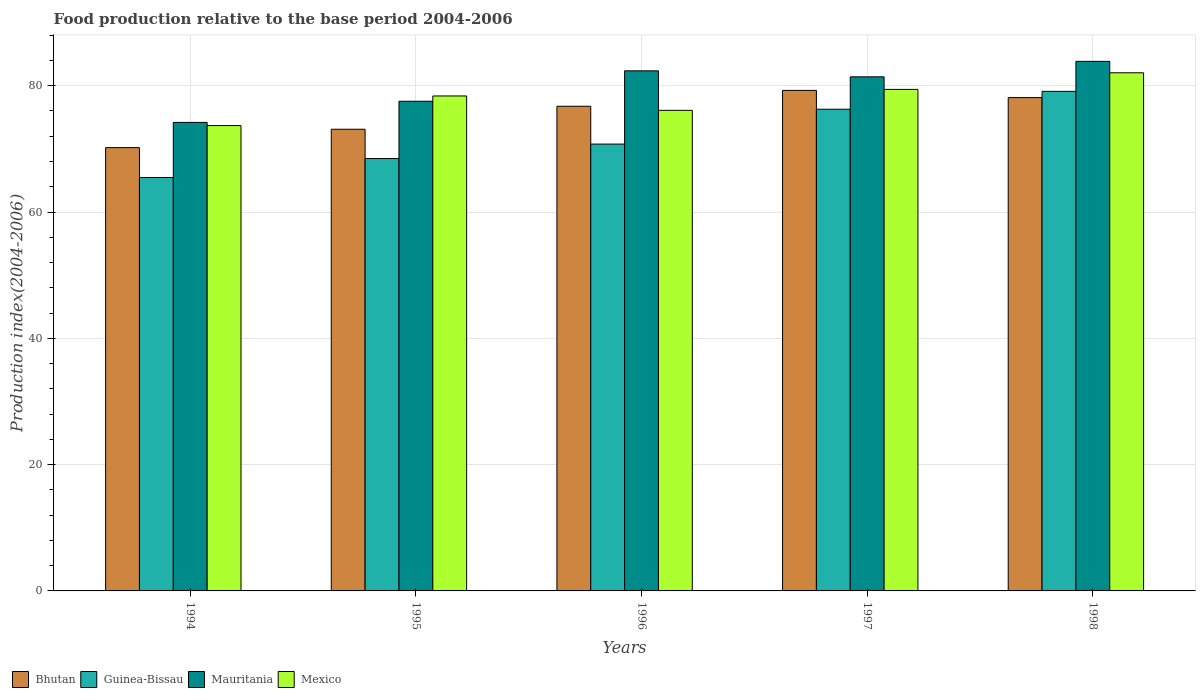Are the number of bars on each tick of the X-axis equal?
Provide a succinct answer. Yes. How many bars are there on the 1st tick from the right?
Give a very brief answer. 4. In how many cases, is the number of bars for a given year not equal to the number of legend labels?
Keep it short and to the point. 0. What is the food production index in Guinea-Bissau in 1996?
Provide a succinct answer. 70.76. Across all years, what is the maximum food production index in Guinea-Bissau?
Your answer should be very brief. 79.11. Across all years, what is the minimum food production index in Mauritania?
Give a very brief answer. 74.19. In which year was the food production index in Mauritania maximum?
Your answer should be very brief. 1998. What is the total food production index in Mexico in the graph?
Keep it short and to the point. 389.64. What is the difference between the food production index in Guinea-Bissau in 1997 and that in 1998?
Keep it short and to the point. -2.83. What is the difference between the food production index in Guinea-Bissau in 1994 and the food production index in Bhutan in 1995?
Give a very brief answer. -7.64. What is the average food production index in Mauritania per year?
Provide a succinct answer. 79.87. In the year 1996, what is the difference between the food production index in Mexico and food production index in Bhutan?
Provide a succinct answer. -0.65. In how many years, is the food production index in Bhutan greater than 24?
Your answer should be compact. 5. What is the ratio of the food production index in Bhutan in 1995 to that in 1997?
Ensure brevity in your answer.  0.92. Is the food production index in Guinea-Bissau in 1997 less than that in 1998?
Provide a short and direct response. Yes. What is the difference between the highest and the second highest food production index in Mexico?
Offer a terse response. 2.63. What is the difference between the highest and the lowest food production index in Mauritania?
Your answer should be very brief. 9.67. Is the sum of the food production index in Mexico in 1994 and 1997 greater than the maximum food production index in Bhutan across all years?
Your response must be concise. Yes. What does the 4th bar from the left in 1997 represents?
Ensure brevity in your answer.  Mexico. What does the 1st bar from the right in 1994 represents?
Offer a terse response. Mexico. Is it the case that in every year, the sum of the food production index in Guinea-Bissau and food production index in Mexico is greater than the food production index in Bhutan?
Keep it short and to the point. Yes. How many bars are there?
Your answer should be very brief. 20. Are the values on the major ticks of Y-axis written in scientific E-notation?
Provide a short and direct response. No. Does the graph contain any zero values?
Provide a short and direct response. No. Does the graph contain grids?
Give a very brief answer. Yes. What is the title of the graph?
Your response must be concise. Food production relative to the base period 2004-2006. Does "Slovenia" appear as one of the legend labels in the graph?
Your answer should be compact. No. What is the label or title of the X-axis?
Keep it short and to the point. Years. What is the label or title of the Y-axis?
Keep it short and to the point. Production index(2004-2006). What is the Production index(2004-2006) of Bhutan in 1994?
Your response must be concise. 70.2. What is the Production index(2004-2006) of Guinea-Bissau in 1994?
Offer a terse response. 65.47. What is the Production index(2004-2006) in Mauritania in 1994?
Your answer should be compact. 74.19. What is the Production index(2004-2006) of Mexico in 1994?
Your answer should be compact. 73.69. What is the Production index(2004-2006) of Bhutan in 1995?
Keep it short and to the point. 73.11. What is the Production index(2004-2006) of Guinea-Bissau in 1995?
Your response must be concise. 68.47. What is the Production index(2004-2006) of Mauritania in 1995?
Your answer should be very brief. 77.54. What is the Production index(2004-2006) in Mexico in 1995?
Your answer should be very brief. 78.38. What is the Production index(2004-2006) in Bhutan in 1996?
Give a very brief answer. 76.75. What is the Production index(2004-2006) in Guinea-Bissau in 1996?
Keep it short and to the point. 70.76. What is the Production index(2004-2006) of Mauritania in 1996?
Keep it short and to the point. 82.36. What is the Production index(2004-2006) in Mexico in 1996?
Ensure brevity in your answer.  76.1. What is the Production index(2004-2006) in Bhutan in 1997?
Offer a very short reply. 79.26. What is the Production index(2004-2006) in Guinea-Bissau in 1997?
Give a very brief answer. 76.28. What is the Production index(2004-2006) in Mauritania in 1997?
Keep it short and to the point. 81.41. What is the Production index(2004-2006) of Mexico in 1997?
Your answer should be very brief. 79.42. What is the Production index(2004-2006) in Bhutan in 1998?
Provide a short and direct response. 78.12. What is the Production index(2004-2006) in Guinea-Bissau in 1998?
Your answer should be compact. 79.11. What is the Production index(2004-2006) of Mauritania in 1998?
Your answer should be very brief. 83.86. What is the Production index(2004-2006) in Mexico in 1998?
Ensure brevity in your answer.  82.05. Across all years, what is the maximum Production index(2004-2006) of Bhutan?
Give a very brief answer. 79.26. Across all years, what is the maximum Production index(2004-2006) of Guinea-Bissau?
Provide a succinct answer. 79.11. Across all years, what is the maximum Production index(2004-2006) of Mauritania?
Your answer should be very brief. 83.86. Across all years, what is the maximum Production index(2004-2006) in Mexico?
Offer a terse response. 82.05. Across all years, what is the minimum Production index(2004-2006) of Bhutan?
Make the answer very short. 70.2. Across all years, what is the minimum Production index(2004-2006) of Guinea-Bissau?
Make the answer very short. 65.47. Across all years, what is the minimum Production index(2004-2006) in Mauritania?
Give a very brief answer. 74.19. Across all years, what is the minimum Production index(2004-2006) in Mexico?
Keep it short and to the point. 73.69. What is the total Production index(2004-2006) in Bhutan in the graph?
Ensure brevity in your answer.  377.44. What is the total Production index(2004-2006) of Guinea-Bissau in the graph?
Your response must be concise. 360.09. What is the total Production index(2004-2006) in Mauritania in the graph?
Keep it short and to the point. 399.36. What is the total Production index(2004-2006) in Mexico in the graph?
Your answer should be very brief. 389.64. What is the difference between the Production index(2004-2006) in Bhutan in 1994 and that in 1995?
Make the answer very short. -2.91. What is the difference between the Production index(2004-2006) in Guinea-Bissau in 1994 and that in 1995?
Provide a succinct answer. -3. What is the difference between the Production index(2004-2006) in Mauritania in 1994 and that in 1995?
Offer a terse response. -3.35. What is the difference between the Production index(2004-2006) in Mexico in 1994 and that in 1995?
Provide a short and direct response. -4.69. What is the difference between the Production index(2004-2006) in Bhutan in 1994 and that in 1996?
Provide a short and direct response. -6.55. What is the difference between the Production index(2004-2006) in Guinea-Bissau in 1994 and that in 1996?
Provide a succinct answer. -5.29. What is the difference between the Production index(2004-2006) of Mauritania in 1994 and that in 1996?
Offer a terse response. -8.17. What is the difference between the Production index(2004-2006) in Mexico in 1994 and that in 1996?
Offer a terse response. -2.41. What is the difference between the Production index(2004-2006) of Bhutan in 1994 and that in 1997?
Provide a succinct answer. -9.06. What is the difference between the Production index(2004-2006) in Guinea-Bissau in 1994 and that in 1997?
Provide a short and direct response. -10.81. What is the difference between the Production index(2004-2006) in Mauritania in 1994 and that in 1997?
Provide a short and direct response. -7.22. What is the difference between the Production index(2004-2006) in Mexico in 1994 and that in 1997?
Give a very brief answer. -5.73. What is the difference between the Production index(2004-2006) in Bhutan in 1994 and that in 1998?
Provide a short and direct response. -7.92. What is the difference between the Production index(2004-2006) in Guinea-Bissau in 1994 and that in 1998?
Ensure brevity in your answer.  -13.64. What is the difference between the Production index(2004-2006) of Mauritania in 1994 and that in 1998?
Your answer should be very brief. -9.67. What is the difference between the Production index(2004-2006) of Mexico in 1994 and that in 1998?
Give a very brief answer. -8.36. What is the difference between the Production index(2004-2006) of Bhutan in 1995 and that in 1996?
Provide a short and direct response. -3.64. What is the difference between the Production index(2004-2006) in Guinea-Bissau in 1995 and that in 1996?
Keep it short and to the point. -2.29. What is the difference between the Production index(2004-2006) of Mauritania in 1995 and that in 1996?
Give a very brief answer. -4.82. What is the difference between the Production index(2004-2006) in Mexico in 1995 and that in 1996?
Give a very brief answer. 2.28. What is the difference between the Production index(2004-2006) of Bhutan in 1995 and that in 1997?
Ensure brevity in your answer.  -6.15. What is the difference between the Production index(2004-2006) in Guinea-Bissau in 1995 and that in 1997?
Provide a succinct answer. -7.81. What is the difference between the Production index(2004-2006) in Mauritania in 1995 and that in 1997?
Ensure brevity in your answer.  -3.87. What is the difference between the Production index(2004-2006) of Mexico in 1995 and that in 1997?
Offer a very short reply. -1.04. What is the difference between the Production index(2004-2006) of Bhutan in 1995 and that in 1998?
Give a very brief answer. -5.01. What is the difference between the Production index(2004-2006) of Guinea-Bissau in 1995 and that in 1998?
Your response must be concise. -10.64. What is the difference between the Production index(2004-2006) in Mauritania in 1995 and that in 1998?
Provide a succinct answer. -6.32. What is the difference between the Production index(2004-2006) in Mexico in 1995 and that in 1998?
Keep it short and to the point. -3.67. What is the difference between the Production index(2004-2006) in Bhutan in 1996 and that in 1997?
Your answer should be very brief. -2.51. What is the difference between the Production index(2004-2006) of Guinea-Bissau in 1996 and that in 1997?
Keep it short and to the point. -5.52. What is the difference between the Production index(2004-2006) in Mauritania in 1996 and that in 1997?
Your answer should be compact. 0.95. What is the difference between the Production index(2004-2006) in Mexico in 1996 and that in 1997?
Make the answer very short. -3.32. What is the difference between the Production index(2004-2006) in Bhutan in 1996 and that in 1998?
Offer a very short reply. -1.37. What is the difference between the Production index(2004-2006) in Guinea-Bissau in 1996 and that in 1998?
Ensure brevity in your answer.  -8.35. What is the difference between the Production index(2004-2006) in Mexico in 1996 and that in 1998?
Offer a terse response. -5.95. What is the difference between the Production index(2004-2006) of Bhutan in 1997 and that in 1998?
Offer a terse response. 1.14. What is the difference between the Production index(2004-2006) of Guinea-Bissau in 1997 and that in 1998?
Provide a short and direct response. -2.83. What is the difference between the Production index(2004-2006) in Mauritania in 1997 and that in 1998?
Offer a terse response. -2.45. What is the difference between the Production index(2004-2006) in Mexico in 1997 and that in 1998?
Make the answer very short. -2.63. What is the difference between the Production index(2004-2006) in Bhutan in 1994 and the Production index(2004-2006) in Guinea-Bissau in 1995?
Your answer should be very brief. 1.73. What is the difference between the Production index(2004-2006) in Bhutan in 1994 and the Production index(2004-2006) in Mauritania in 1995?
Provide a short and direct response. -7.34. What is the difference between the Production index(2004-2006) in Bhutan in 1994 and the Production index(2004-2006) in Mexico in 1995?
Your answer should be very brief. -8.18. What is the difference between the Production index(2004-2006) in Guinea-Bissau in 1994 and the Production index(2004-2006) in Mauritania in 1995?
Offer a terse response. -12.07. What is the difference between the Production index(2004-2006) in Guinea-Bissau in 1994 and the Production index(2004-2006) in Mexico in 1995?
Provide a short and direct response. -12.91. What is the difference between the Production index(2004-2006) in Mauritania in 1994 and the Production index(2004-2006) in Mexico in 1995?
Your answer should be compact. -4.19. What is the difference between the Production index(2004-2006) in Bhutan in 1994 and the Production index(2004-2006) in Guinea-Bissau in 1996?
Your answer should be compact. -0.56. What is the difference between the Production index(2004-2006) in Bhutan in 1994 and the Production index(2004-2006) in Mauritania in 1996?
Make the answer very short. -12.16. What is the difference between the Production index(2004-2006) in Bhutan in 1994 and the Production index(2004-2006) in Mexico in 1996?
Your answer should be very brief. -5.9. What is the difference between the Production index(2004-2006) in Guinea-Bissau in 1994 and the Production index(2004-2006) in Mauritania in 1996?
Provide a succinct answer. -16.89. What is the difference between the Production index(2004-2006) in Guinea-Bissau in 1994 and the Production index(2004-2006) in Mexico in 1996?
Offer a terse response. -10.63. What is the difference between the Production index(2004-2006) of Mauritania in 1994 and the Production index(2004-2006) of Mexico in 1996?
Keep it short and to the point. -1.91. What is the difference between the Production index(2004-2006) of Bhutan in 1994 and the Production index(2004-2006) of Guinea-Bissau in 1997?
Offer a terse response. -6.08. What is the difference between the Production index(2004-2006) of Bhutan in 1994 and the Production index(2004-2006) of Mauritania in 1997?
Your answer should be very brief. -11.21. What is the difference between the Production index(2004-2006) of Bhutan in 1994 and the Production index(2004-2006) of Mexico in 1997?
Provide a short and direct response. -9.22. What is the difference between the Production index(2004-2006) of Guinea-Bissau in 1994 and the Production index(2004-2006) of Mauritania in 1997?
Ensure brevity in your answer.  -15.94. What is the difference between the Production index(2004-2006) of Guinea-Bissau in 1994 and the Production index(2004-2006) of Mexico in 1997?
Make the answer very short. -13.95. What is the difference between the Production index(2004-2006) in Mauritania in 1994 and the Production index(2004-2006) in Mexico in 1997?
Provide a succinct answer. -5.23. What is the difference between the Production index(2004-2006) in Bhutan in 1994 and the Production index(2004-2006) in Guinea-Bissau in 1998?
Provide a short and direct response. -8.91. What is the difference between the Production index(2004-2006) in Bhutan in 1994 and the Production index(2004-2006) in Mauritania in 1998?
Provide a short and direct response. -13.66. What is the difference between the Production index(2004-2006) in Bhutan in 1994 and the Production index(2004-2006) in Mexico in 1998?
Provide a succinct answer. -11.85. What is the difference between the Production index(2004-2006) in Guinea-Bissau in 1994 and the Production index(2004-2006) in Mauritania in 1998?
Your response must be concise. -18.39. What is the difference between the Production index(2004-2006) in Guinea-Bissau in 1994 and the Production index(2004-2006) in Mexico in 1998?
Offer a very short reply. -16.58. What is the difference between the Production index(2004-2006) of Mauritania in 1994 and the Production index(2004-2006) of Mexico in 1998?
Provide a short and direct response. -7.86. What is the difference between the Production index(2004-2006) of Bhutan in 1995 and the Production index(2004-2006) of Guinea-Bissau in 1996?
Provide a short and direct response. 2.35. What is the difference between the Production index(2004-2006) in Bhutan in 1995 and the Production index(2004-2006) in Mauritania in 1996?
Give a very brief answer. -9.25. What is the difference between the Production index(2004-2006) of Bhutan in 1995 and the Production index(2004-2006) of Mexico in 1996?
Give a very brief answer. -2.99. What is the difference between the Production index(2004-2006) of Guinea-Bissau in 1995 and the Production index(2004-2006) of Mauritania in 1996?
Make the answer very short. -13.89. What is the difference between the Production index(2004-2006) in Guinea-Bissau in 1995 and the Production index(2004-2006) in Mexico in 1996?
Keep it short and to the point. -7.63. What is the difference between the Production index(2004-2006) of Mauritania in 1995 and the Production index(2004-2006) of Mexico in 1996?
Give a very brief answer. 1.44. What is the difference between the Production index(2004-2006) of Bhutan in 1995 and the Production index(2004-2006) of Guinea-Bissau in 1997?
Your answer should be compact. -3.17. What is the difference between the Production index(2004-2006) in Bhutan in 1995 and the Production index(2004-2006) in Mauritania in 1997?
Make the answer very short. -8.3. What is the difference between the Production index(2004-2006) in Bhutan in 1995 and the Production index(2004-2006) in Mexico in 1997?
Your answer should be very brief. -6.31. What is the difference between the Production index(2004-2006) of Guinea-Bissau in 1995 and the Production index(2004-2006) of Mauritania in 1997?
Ensure brevity in your answer.  -12.94. What is the difference between the Production index(2004-2006) in Guinea-Bissau in 1995 and the Production index(2004-2006) in Mexico in 1997?
Offer a very short reply. -10.95. What is the difference between the Production index(2004-2006) in Mauritania in 1995 and the Production index(2004-2006) in Mexico in 1997?
Your response must be concise. -1.88. What is the difference between the Production index(2004-2006) of Bhutan in 1995 and the Production index(2004-2006) of Guinea-Bissau in 1998?
Provide a succinct answer. -6. What is the difference between the Production index(2004-2006) of Bhutan in 1995 and the Production index(2004-2006) of Mauritania in 1998?
Provide a short and direct response. -10.75. What is the difference between the Production index(2004-2006) in Bhutan in 1995 and the Production index(2004-2006) in Mexico in 1998?
Keep it short and to the point. -8.94. What is the difference between the Production index(2004-2006) of Guinea-Bissau in 1995 and the Production index(2004-2006) of Mauritania in 1998?
Offer a very short reply. -15.39. What is the difference between the Production index(2004-2006) of Guinea-Bissau in 1995 and the Production index(2004-2006) of Mexico in 1998?
Give a very brief answer. -13.58. What is the difference between the Production index(2004-2006) in Mauritania in 1995 and the Production index(2004-2006) in Mexico in 1998?
Offer a terse response. -4.51. What is the difference between the Production index(2004-2006) of Bhutan in 1996 and the Production index(2004-2006) of Guinea-Bissau in 1997?
Your answer should be compact. 0.47. What is the difference between the Production index(2004-2006) in Bhutan in 1996 and the Production index(2004-2006) in Mauritania in 1997?
Provide a succinct answer. -4.66. What is the difference between the Production index(2004-2006) of Bhutan in 1996 and the Production index(2004-2006) of Mexico in 1997?
Keep it short and to the point. -2.67. What is the difference between the Production index(2004-2006) of Guinea-Bissau in 1996 and the Production index(2004-2006) of Mauritania in 1997?
Ensure brevity in your answer.  -10.65. What is the difference between the Production index(2004-2006) of Guinea-Bissau in 1996 and the Production index(2004-2006) of Mexico in 1997?
Your answer should be compact. -8.66. What is the difference between the Production index(2004-2006) in Mauritania in 1996 and the Production index(2004-2006) in Mexico in 1997?
Your answer should be compact. 2.94. What is the difference between the Production index(2004-2006) of Bhutan in 1996 and the Production index(2004-2006) of Guinea-Bissau in 1998?
Keep it short and to the point. -2.36. What is the difference between the Production index(2004-2006) of Bhutan in 1996 and the Production index(2004-2006) of Mauritania in 1998?
Ensure brevity in your answer.  -7.11. What is the difference between the Production index(2004-2006) of Guinea-Bissau in 1996 and the Production index(2004-2006) of Mauritania in 1998?
Ensure brevity in your answer.  -13.1. What is the difference between the Production index(2004-2006) in Guinea-Bissau in 1996 and the Production index(2004-2006) in Mexico in 1998?
Ensure brevity in your answer.  -11.29. What is the difference between the Production index(2004-2006) of Mauritania in 1996 and the Production index(2004-2006) of Mexico in 1998?
Provide a short and direct response. 0.31. What is the difference between the Production index(2004-2006) in Bhutan in 1997 and the Production index(2004-2006) in Mauritania in 1998?
Keep it short and to the point. -4.6. What is the difference between the Production index(2004-2006) of Bhutan in 1997 and the Production index(2004-2006) of Mexico in 1998?
Offer a terse response. -2.79. What is the difference between the Production index(2004-2006) in Guinea-Bissau in 1997 and the Production index(2004-2006) in Mauritania in 1998?
Ensure brevity in your answer.  -7.58. What is the difference between the Production index(2004-2006) of Guinea-Bissau in 1997 and the Production index(2004-2006) of Mexico in 1998?
Offer a terse response. -5.77. What is the difference between the Production index(2004-2006) in Mauritania in 1997 and the Production index(2004-2006) in Mexico in 1998?
Your response must be concise. -0.64. What is the average Production index(2004-2006) of Bhutan per year?
Offer a terse response. 75.49. What is the average Production index(2004-2006) in Guinea-Bissau per year?
Offer a terse response. 72.02. What is the average Production index(2004-2006) of Mauritania per year?
Offer a very short reply. 79.87. What is the average Production index(2004-2006) in Mexico per year?
Your answer should be compact. 77.93. In the year 1994, what is the difference between the Production index(2004-2006) of Bhutan and Production index(2004-2006) of Guinea-Bissau?
Your answer should be very brief. 4.73. In the year 1994, what is the difference between the Production index(2004-2006) of Bhutan and Production index(2004-2006) of Mauritania?
Your answer should be very brief. -3.99. In the year 1994, what is the difference between the Production index(2004-2006) in Bhutan and Production index(2004-2006) in Mexico?
Ensure brevity in your answer.  -3.49. In the year 1994, what is the difference between the Production index(2004-2006) in Guinea-Bissau and Production index(2004-2006) in Mauritania?
Your answer should be compact. -8.72. In the year 1994, what is the difference between the Production index(2004-2006) of Guinea-Bissau and Production index(2004-2006) of Mexico?
Your response must be concise. -8.22. In the year 1994, what is the difference between the Production index(2004-2006) of Mauritania and Production index(2004-2006) of Mexico?
Keep it short and to the point. 0.5. In the year 1995, what is the difference between the Production index(2004-2006) in Bhutan and Production index(2004-2006) in Guinea-Bissau?
Ensure brevity in your answer.  4.64. In the year 1995, what is the difference between the Production index(2004-2006) in Bhutan and Production index(2004-2006) in Mauritania?
Keep it short and to the point. -4.43. In the year 1995, what is the difference between the Production index(2004-2006) of Bhutan and Production index(2004-2006) of Mexico?
Offer a very short reply. -5.27. In the year 1995, what is the difference between the Production index(2004-2006) in Guinea-Bissau and Production index(2004-2006) in Mauritania?
Make the answer very short. -9.07. In the year 1995, what is the difference between the Production index(2004-2006) of Guinea-Bissau and Production index(2004-2006) of Mexico?
Provide a succinct answer. -9.91. In the year 1995, what is the difference between the Production index(2004-2006) of Mauritania and Production index(2004-2006) of Mexico?
Provide a short and direct response. -0.84. In the year 1996, what is the difference between the Production index(2004-2006) of Bhutan and Production index(2004-2006) of Guinea-Bissau?
Your answer should be compact. 5.99. In the year 1996, what is the difference between the Production index(2004-2006) of Bhutan and Production index(2004-2006) of Mauritania?
Give a very brief answer. -5.61. In the year 1996, what is the difference between the Production index(2004-2006) in Bhutan and Production index(2004-2006) in Mexico?
Provide a short and direct response. 0.65. In the year 1996, what is the difference between the Production index(2004-2006) in Guinea-Bissau and Production index(2004-2006) in Mexico?
Ensure brevity in your answer.  -5.34. In the year 1996, what is the difference between the Production index(2004-2006) of Mauritania and Production index(2004-2006) of Mexico?
Your answer should be very brief. 6.26. In the year 1997, what is the difference between the Production index(2004-2006) in Bhutan and Production index(2004-2006) in Guinea-Bissau?
Offer a terse response. 2.98. In the year 1997, what is the difference between the Production index(2004-2006) in Bhutan and Production index(2004-2006) in Mauritania?
Offer a terse response. -2.15. In the year 1997, what is the difference between the Production index(2004-2006) in Bhutan and Production index(2004-2006) in Mexico?
Ensure brevity in your answer.  -0.16. In the year 1997, what is the difference between the Production index(2004-2006) of Guinea-Bissau and Production index(2004-2006) of Mauritania?
Provide a succinct answer. -5.13. In the year 1997, what is the difference between the Production index(2004-2006) in Guinea-Bissau and Production index(2004-2006) in Mexico?
Offer a very short reply. -3.14. In the year 1997, what is the difference between the Production index(2004-2006) in Mauritania and Production index(2004-2006) in Mexico?
Give a very brief answer. 1.99. In the year 1998, what is the difference between the Production index(2004-2006) of Bhutan and Production index(2004-2006) of Guinea-Bissau?
Make the answer very short. -0.99. In the year 1998, what is the difference between the Production index(2004-2006) of Bhutan and Production index(2004-2006) of Mauritania?
Provide a succinct answer. -5.74. In the year 1998, what is the difference between the Production index(2004-2006) of Bhutan and Production index(2004-2006) of Mexico?
Your answer should be compact. -3.93. In the year 1998, what is the difference between the Production index(2004-2006) of Guinea-Bissau and Production index(2004-2006) of Mauritania?
Give a very brief answer. -4.75. In the year 1998, what is the difference between the Production index(2004-2006) of Guinea-Bissau and Production index(2004-2006) of Mexico?
Offer a terse response. -2.94. In the year 1998, what is the difference between the Production index(2004-2006) in Mauritania and Production index(2004-2006) in Mexico?
Provide a succinct answer. 1.81. What is the ratio of the Production index(2004-2006) of Bhutan in 1994 to that in 1995?
Your answer should be compact. 0.96. What is the ratio of the Production index(2004-2006) in Guinea-Bissau in 1994 to that in 1995?
Give a very brief answer. 0.96. What is the ratio of the Production index(2004-2006) of Mauritania in 1994 to that in 1995?
Offer a very short reply. 0.96. What is the ratio of the Production index(2004-2006) in Mexico in 1994 to that in 1995?
Offer a terse response. 0.94. What is the ratio of the Production index(2004-2006) of Bhutan in 1994 to that in 1996?
Provide a short and direct response. 0.91. What is the ratio of the Production index(2004-2006) in Guinea-Bissau in 1994 to that in 1996?
Provide a succinct answer. 0.93. What is the ratio of the Production index(2004-2006) in Mauritania in 1994 to that in 1996?
Offer a very short reply. 0.9. What is the ratio of the Production index(2004-2006) of Mexico in 1994 to that in 1996?
Ensure brevity in your answer.  0.97. What is the ratio of the Production index(2004-2006) in Bhutan in 1994 to that in 1997?
Your answer should be very brief. 0.89. What is the ratio of the Production index(2004-2006) of Guinea-Bissau in 1994 to that in 1997?
Your answer should be compact. 0.86. What is the ratio of the Production index(2004-2006) of Mauritania in 1994 to that in 1997?
Your answer should be compact. 0.91. What is the ratio of the Production index(2004-2006) of Mexico in 1994 to that in 1997?
Your response must be concise. 0.93. What is the ratio of the Production index(2004-2006) in Bhutan in 1994 to that in 1998?
Provide a succinct answer. 0.9. What is the ratio of the Production index(2004-2006) of Guinea-Bissau in 1994 to that in 1998?
Your answer should be compact. 0.83. What is the ratio of the Production index(2004-2006) in Mauritania in 1994 to that in 1998?
Offer a terse response. 0.88. What is the ratio of the Production index(2004-2006) in Mexico in 1994 to that in 1998?
Offer a very short reply. 0.9. What is the ratio of the Production index(2004-2006) in Bhutan in 1995 to that in 1996?
Provide a short and direct response. 0.95. What is the ratio of the Production index(2004-2006) of Guinea-Bissau in 1995 to that in 1996?
Make the answer very short. 0.97. What is the ratio of the Production index(2004-2006) of Mauritania in 1995 to that in 1996?
Offer a terse response. 0.94. What is the ratio of the Production index(2004-2006) of Mexico in 1995 to that in 1996?
Offer a very short reply. 1.03. What is the ratio of the Production index(2004-2006) in Bhutan in 1995 to that in 1997?
Your answer should be compact. 0.92. What is the ratio of the Production index(2004-2006) in Guinea-Bissau in 1995 to that in 1997?
Provide a succinct answer. 0.9. What is the ratio of the Production index(2004-2006) in Mauritania in 1995 to that in 1997?
Provide a succinct answer. 0.95. What is the ratio of the Production index(2004-2006) of Mexico in 1995 to that in 1997?
Make the answer very short. 0.99. What is the ratio of the Production index(2004-2006) in Bhutan in 1995 to that in 1998?
Your answer should be very brief. 0.94. What is the ratio of the Production index(2004-2006) in Guinea-Bissau in 1995 to that in 1998?
Your answer should be compact. 0.87. What is the ratio of the Production index(2004-2006) of Mauritania in 1995 to that in 1998?
Offer a very short reply. 0.92. What is the ratio of the Production index(2004-2006) in Mexico in 1995 to that in 1998?
Offer a very short reply. 0.96. What is the ratio of the Production index(2004-2006) of Bhutan in 1996 to that in 1997?
Offer a very short reply. 0.97. What is the ratio of the Production index(2004-2006) in Guinea-Bissau in 1996 to that in 1997?
Give a very brief answer. 0.93. What is the ratio of the Production index(2004-2006) of Mauritania in 1996 to that in 1997?
Ensure brevity in your answer.  1.01. What is the ratio of the Production index(2004-2006) in Mexico in 1996 to that in 1997?
Your answer should be compact. 0.96. What is the ratio of the Production index(2004-2006) in Bhutan in 1996 to that in 1998?
Offer a very short reply. 0.98. What is the ratio of the Production index(2004-2006) in Guinea-Bissau in 1996 to that in 1998?
Keep it short and to the point. 0.89. What is the ratio of the Production index(2004-2006) of Mauritania in 1996 to that in 1998?
Provide a succinct answer. 0.98. What is the ratio of the Production index(2004-2006) in Mexico in 1996 to that in 1998?
Keep it short and to the point. 0.93. What is the ratio of the Production index(2004-2006) of Bhutan in 1997 to that in 1998?
Your response must be concise. 1.01. What is the ratio of the Production index(2004-2006) in Guinea-Bissau in 1997 to that in 1998?
Provide a succinct answer. 0.96. What is the ratio of the Production index(2004-2006) in Mauritania in 1997 to that in 1998?
Provide a short and direct response. 0.97. What is the ratio of the Production index(2004-2006) in Mexico in 1997 to that in 1998?
Your answer should be very brief. 0.97. What is the difference between the highest and the second highest Production index(2004-2006) of Bhutan?
Provide a succinct answer. 1.14. What is the difference between the highest and the second highest Production index(2004-2006) of Guinea-Bissau?
Make the answer very short. 2.83. What is the difference between the highest and the second highest Production index(2004-2006) of Mauritania?
Provide a succinct answer. 1.5. What is the difference between the highest and the second highest Production index(2004-2006) in Mexico?
Provide a short and direct response. 2.63. What is the difference between the highest and the lowest Production index(2004-2006) in Bhutan?
Keep it short and to the point. 9.06. What is the difference between the highest and the lowest Production index(2004-2006) in Guinea-Bissau?
Your answer should be very brief. 13.64. What is the difference between the highest and the lowest Production index(2004-2006) of Mauritania?
Provide a short and direct response. 9.67. What is the difference between the highest and the lowest Production index(2004-2006) of Mexico?
Your response must be concise. 8.36. 